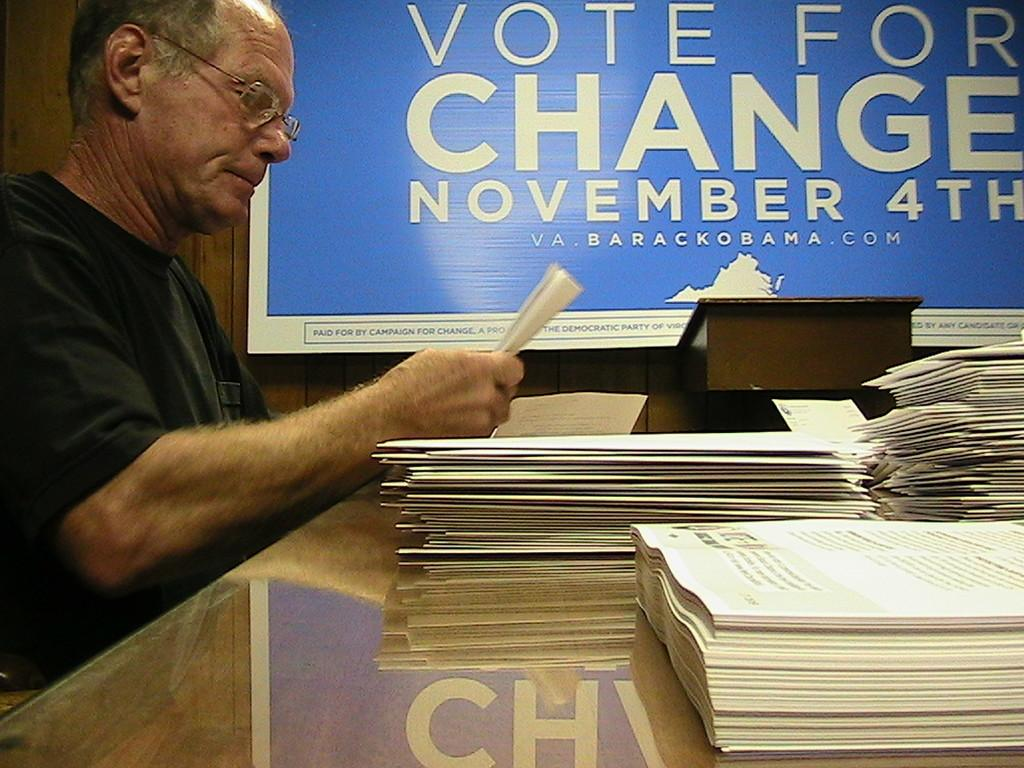<image>
Relay a brief, clear account of the picture shown. A man holding a piece of paper at a table with booklets in front of a sign saying to vote for change November 4th. 